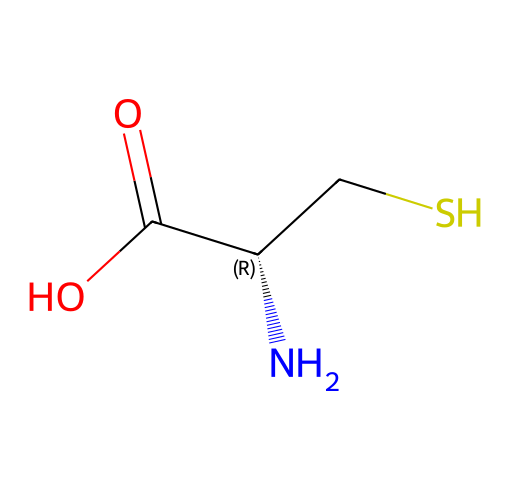What is the central atom in the molecular structure? The central atom in this structure is carbon, identified as it is directly bonded to other groups and located in the backbone of the structure.
Answer: carbon How many sulfur atoms are present in this molecule? There is one sulfur atom in this molecule, indicated by the 'S' in the SMILES representation, which is attached to a carbon and plays a crucial role in the molecule's properties.
Answer: one What functional group is represented by the -SH in the structure? The -SH group is known as a thiol functional group, related to the presence of sulfur bonded to hydrogen, which is characteristic of cysteine as an organosulfur compound.
Answer: thiol How many chiral centers are present in cysteine? Cysteine has one chiral center, as indicated by the chiral carbon (C@@H) that is connected to four distinct groups: an amino group, a carboxyl group, a hydrogen atom, and a thiol group.
Answer: one What type of bonding contributes to the protein folding capabilities of cysteine? The protein folding capabilities of cysteine are primarily due to disulfide bonds formed between thiol groups of cysteine residues, which stabilize protein structures.
Answer: disulfide bonds What is the total number of atoms in cysteine? Cysteine contains a total of 6 atoms, comprising 3 carbon (C), 7 hydrogen (H), 1 nitrogen (N), 1 sulfur (S), and 2 oxygen (O) atoms based on the elemental symbols in the SMILES representation.
Answer: six What classification does cysteine fall under regarding its solubility? Cysteine is classified as a polar amino acid, which tends to be soluble in water due to the presence of its hydrophilic functional groups (amino and carboxyl groups) and thiol group.
Answer: polar 